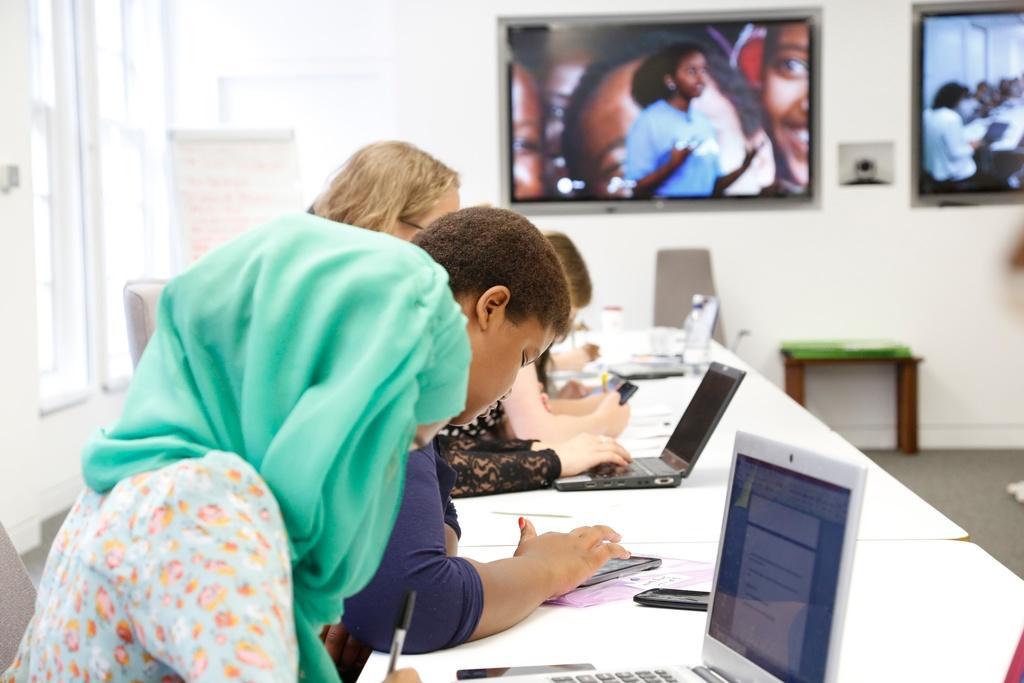Could you give a brief overview of what you see in this image? In this image there are group of people who are sitting on a chair in front of them there is one table on that table there are laptops and, on the background there are two televisions and on the left side there is a wall and on the top of the left side there is a window. On the right side there is a stool on the floor. 